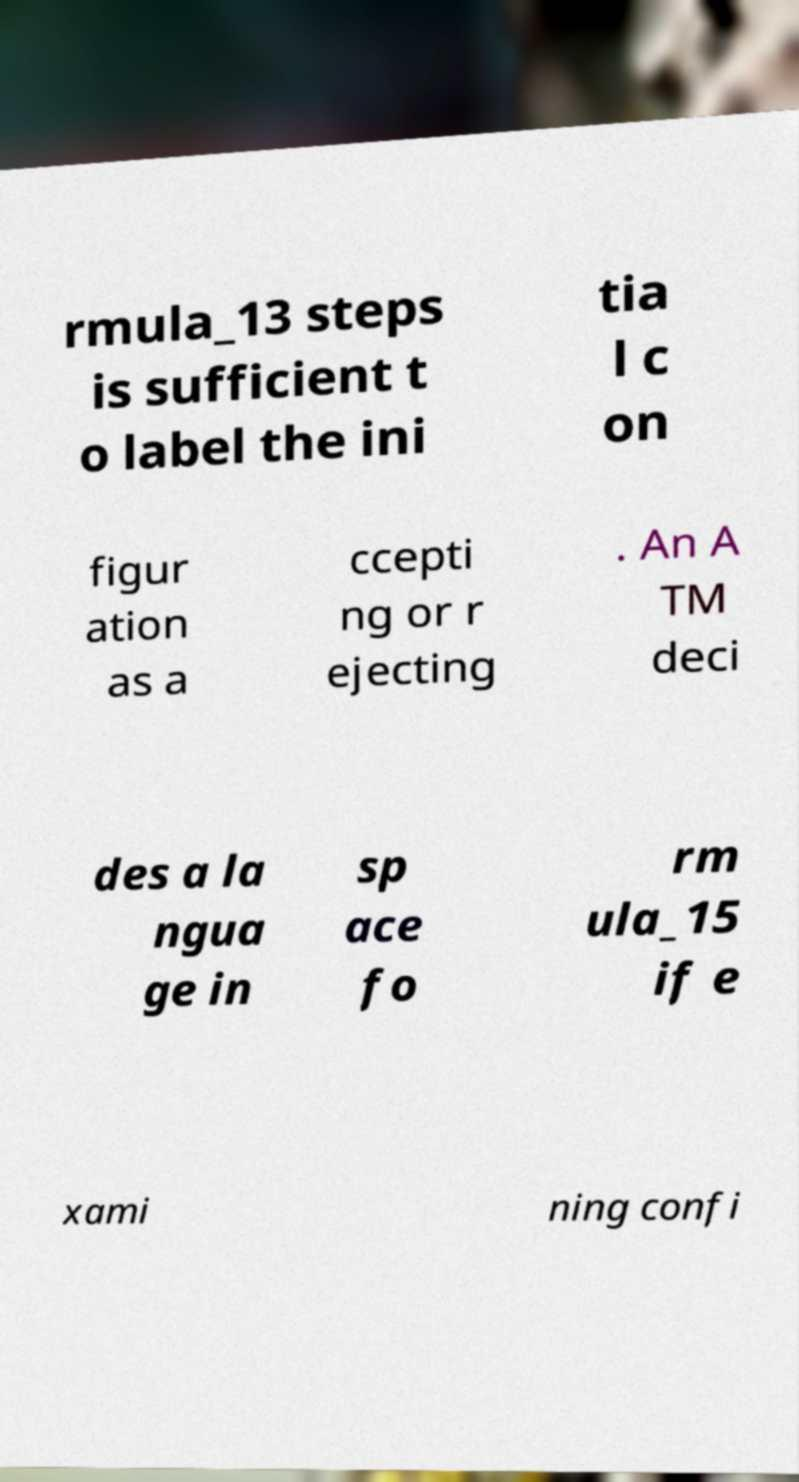What messages or text are displayed in this image? I need them in a readable, typed format. rmula_13 steps is sufficient t o label the ini tia l c on figur ation as a ccepti ng or r ejecting . An A TM deci des a la ngua ge in sp ace fo rm ula_15 if e xami ning confi 